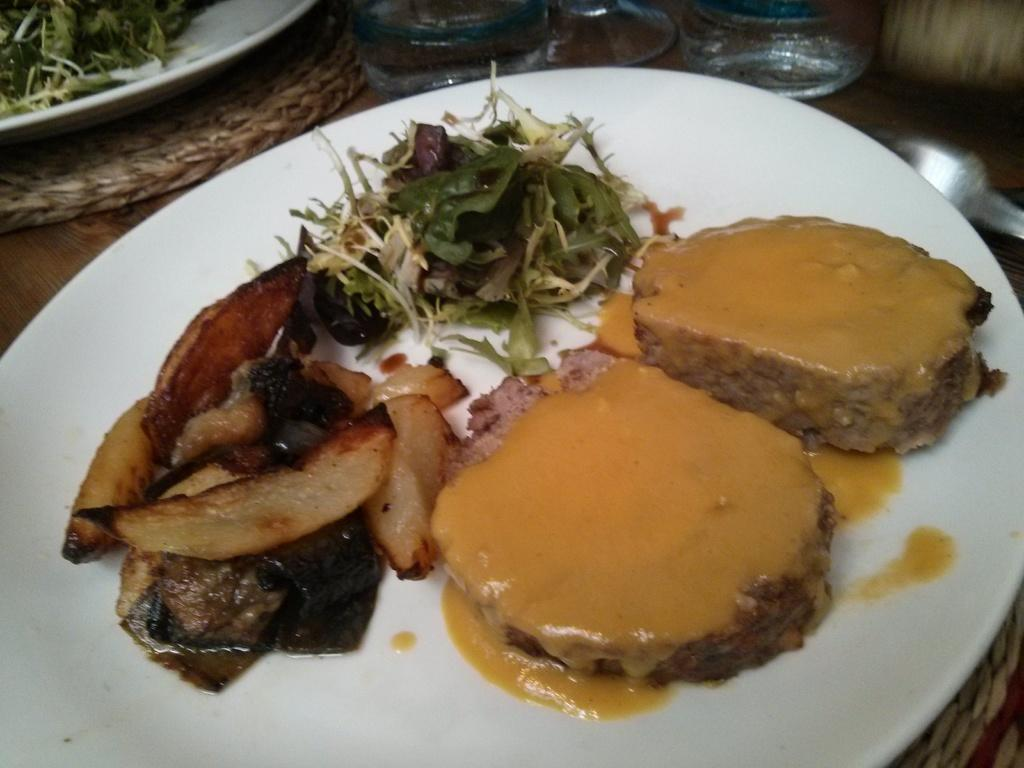What type of objects can be seen in the image? There are plates, food items, spoons, glasses, and mats in the image. How are these objects arranged? All of these objects are placed on a platform. What might be used for eating the food items in the image? The spoons in the image can be used for eating the food items. What might be used for drinking in the image? The glasses in the image can be used for drinking. What type of current can be seen flowing through the food items in the image? There is no current flowing through the food items in the image; it is a still image. What type of border is present around the mats in the image? There is no border present around the mats in the image; they are simply placed on the platform. 